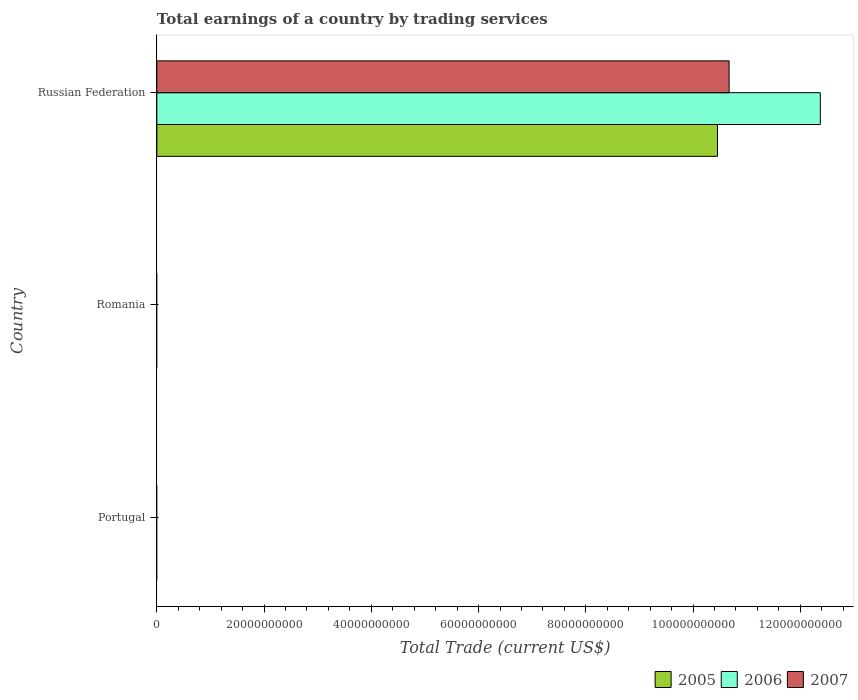How many different coloured bars are there?
Your response must be concise. 3. Are the number of bars per tick equal to the number of legend labels?
Keep it short and to the point. No. What is the label of the 3rd group of bars from the top?
Your answer should be very brief. Portugal. What is the total earnings in 2005 in Russian Federation?
Offer a very short reply. 1.05e+11. Across all countries, what is the maximum total earnings in 2007?
Ensure brevity in your answer.  1.07e+11. Across all countries, what is the minimum total earnings in 2007?
Your answer should be very brief. 0. In which country was the total earnings in 2007 maximum?
Provide a short and direct response. Russian Federation. What is the total total earnings in 2007 in the graph?
Your answer should be compact. 1.07e+11. What is the difference between the total earnings in 2007 in Romania and the total earnings in 2006 in Russian Federation?
Make the answer very short. -1.24e+11. What is the average total earnings in 2005 per country?
Provide a short and direct response. 3.49e+1. What is the difference between the total earnings in 2007 and total earnings in 2006 in Russian Federation?
Offer a terse response. -1.70e+1. In how many countries, is the total earnings in 2007 greater than 96000000000 US$?
Offer a very short reply. 1. What is the difference between the highest and the lowest total earnings in 2005?
Provide a succinct answer. 1.05e+11. Is it the case that in every country, the sum of the total earnings in 2006 and total earnings in 2007 is greater than the total earnings in 2005?
Your answer should be very brief. No. How many countries are there in the graph?
Offer a terse response. 3. Does the graph contain any zero values?
Your answer should be compact. Yes. How are the legend labels stacked?
Your answer should be very brief. Horizontal. What is the title of the graph?
Keep it short and to the point. Total earnings of a country by trading services. What is the label or title of the X-axis?
Your answer should be very brief. Total Trade (current US$). What is the label or title of the Y-axis?
Make the answer very short. Country. What is the Total Trade (current US$) of 2006 in Portugal?
Provide a succinct answer. 0. What is the Total Trade (current US$) of 2007 in Romania?
Provide a succinct answer. 0. What is the Total Trade (current US$) in 2005 in Russian Federation?
Make the answer very short. 1.05e+11. What is the Total Trade (current US$) in 2006 in Russian Federation?
Ensure brevity in your answer.  1.24e+11. What is the Total Trade (current US$) of 2007 in Russian Federation?
Provide a succinct answer. 1.07e+11. Across all countries, what is the maximum Total Trade (current US$) of 2005?
Your answer should be very brief. 1.05e+11. Across all countries, what is the maximum Total Trade (current US$) of 2006?
Keep it short and to the point. 1.24e+11. Across all countries, what is the maximum Total Trade (current US$) in 2007?
Give a very brief answer. 1.07e+11. Across all countries, what is the minimum Total Trade (current US$) of 2007?
Your answer should be compact. 0. What is the total Total Trade (current US$) of 2005 in the graph?
Your response must be concise. 1.05e+11. What is the total Total Trade (current US$) in 2006 in the graph?
Your answer should be compact. 1.24e+11. What is the total Total Trade (current US$) in 2007 in the graph?
Make the answer very short. 1.07e+11. What is the average Total Trade (current US$) of 2005 per country?
Keep it short and to the point. 3.49e+1. What is the average Total Trade (current US$) in 2006 per country?
Your answer should be compact. 4.12e+1. What is the average Total Trade (current US$) of 2007 per country?
Offer a very short reply. 3.56e+1. What is the difference between the Total Trade (current US$) of 2005 and Total Trade (current US$) of 2006 in Russian Federation?
Offer a very short reply. -1.92e+1. What is the difference between the Total Trade (current US$) of 2005 and Total Trade (current US$) of 2007 in Russian Federation?
Your answer should be compact. -2.17e+09. What is the difference between the Total Trade (current US$) of 2006 and Total Trade (current US$) of 2007 in Russian Federation?
Make the answer very short. 1.70e+1. What is the difference between the highest and the lowest Total Trade (current US$) of 2005?
Give a very brief answer. 1.05e+11. What is the difference between the highest and the lowest Total Trade (current US$) of 2006?
Offer a very short reply. 1.24e+11. What is the difference between the highest and the lowest Total Trade (current US$) of 2007?
Keep it short and to the point. 1.07e+11. 